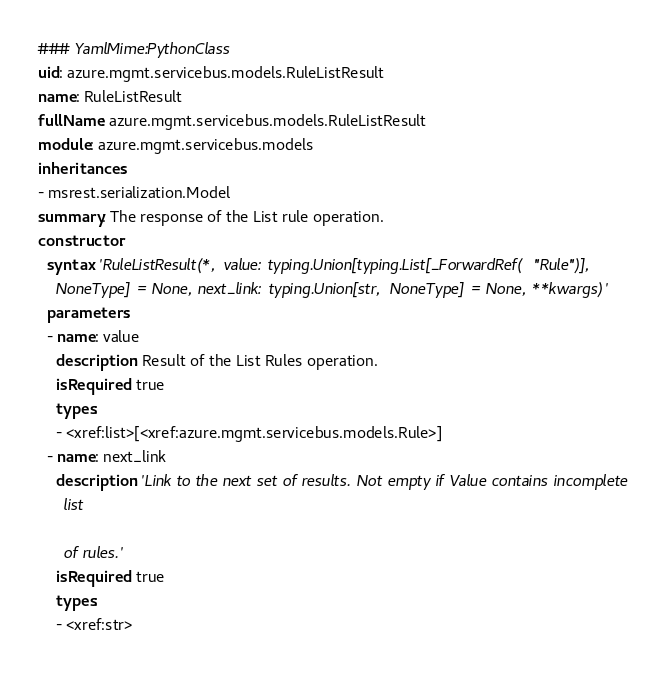Convert code to text. <code><loc_0><loc_0><loc_500><loc_500><_YAML_>### YamlMime:PythonClass
uid: azure.mgmt.servicebus.models.RuleListResult
name: RuleListResult
fullName: azure.mgmt.servicebus.models.RuleListResult
module: azure.mgmt.servicebus.models
inheritances:
- msrest.serialization.Model
summary: The response of the List rule operation.
constructor:
  syntax: 'RuleListResult(*, value: typing.Union[typing.List[_ForwardRef(''Rule'')],
    NoneType] = None, next_link: typing.Union[str, NoneType] = None, **kwargs)'
  parameters:
  - name: value
    description: Result of the List Rules operation.
    isRequired: true
    types:
    - <xref:list>[<xref:azure.mgmt.servicebus.models.Rule>]
  - name: next_link
    description: 'Link to the next set of results. Not empty if Value contains incomplete
      list

      of rules.'
    isRequired: true
    types:
    - <xref:str>
</code> 